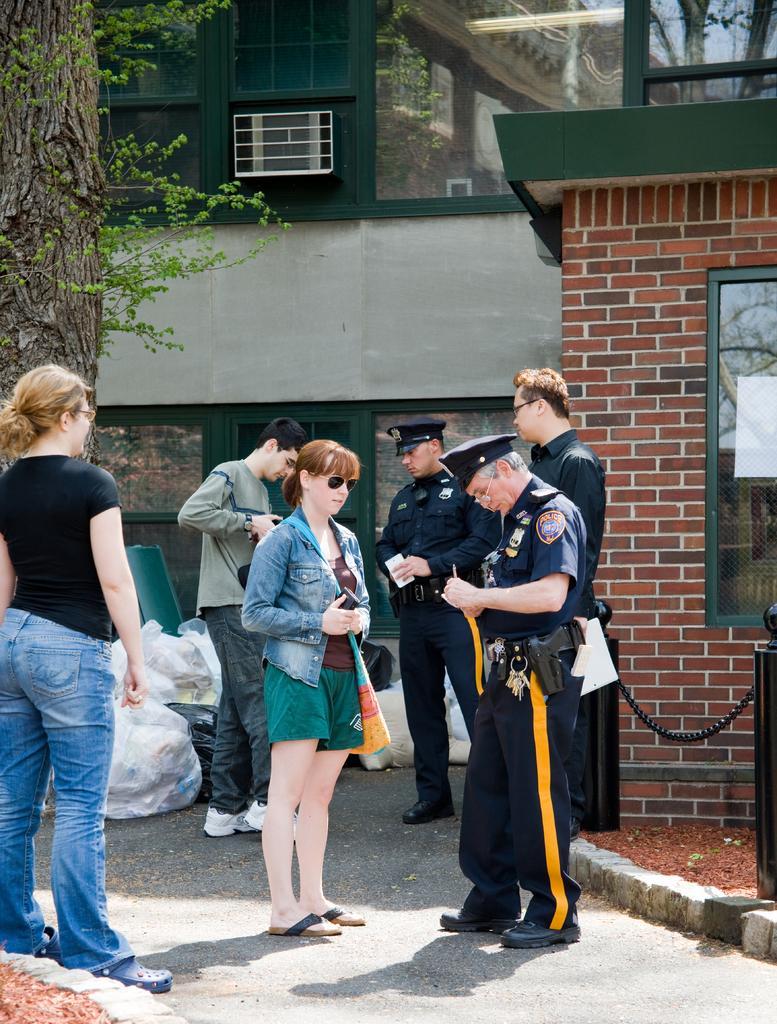Describe this image in one or two sentences. There are people and cops standing in the foreground area of the image, there are garbage polythene, buildings and the tree in the background. 